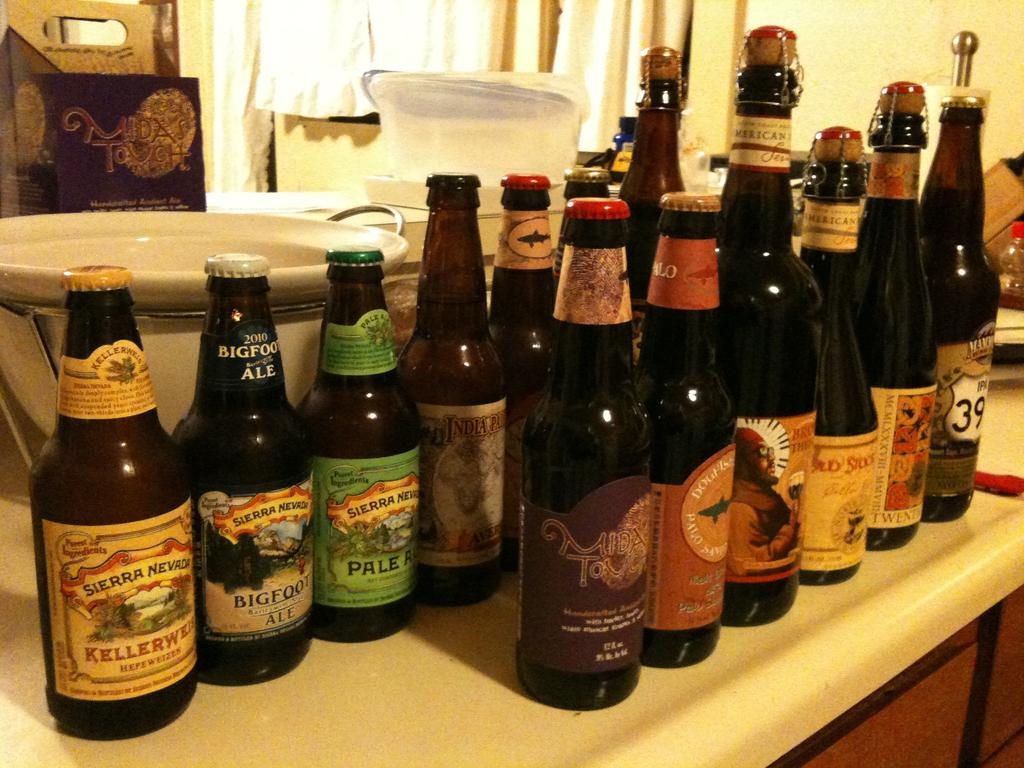Provide a one-sentence caption for the provided image. A bottle of big foot ale is on a counter with other bottles. 